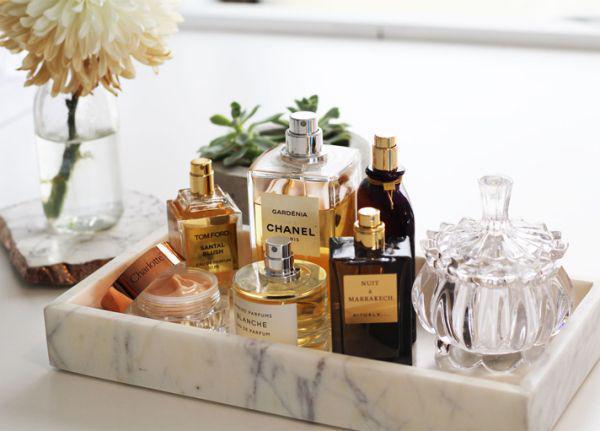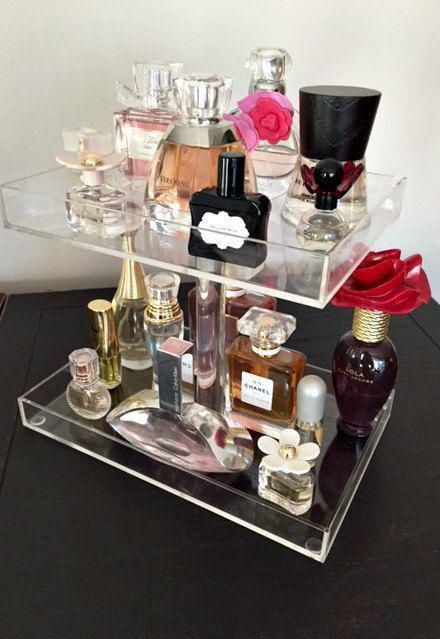The first image is the image on the left, the second image is the image on the right. For the images shown, is this caption "Each image features one display with multiple levels, and one image shows a white wall-mounted display with scrolling shapes on the top and bottom." true? Answer yes or no. No. The first image is the image on the left, the second image is the image on the right. Analyze the images presented: Is the assertion "There are two tiers of shelves in the display in the image on the right." valid? Answer yes or no. Yes. 